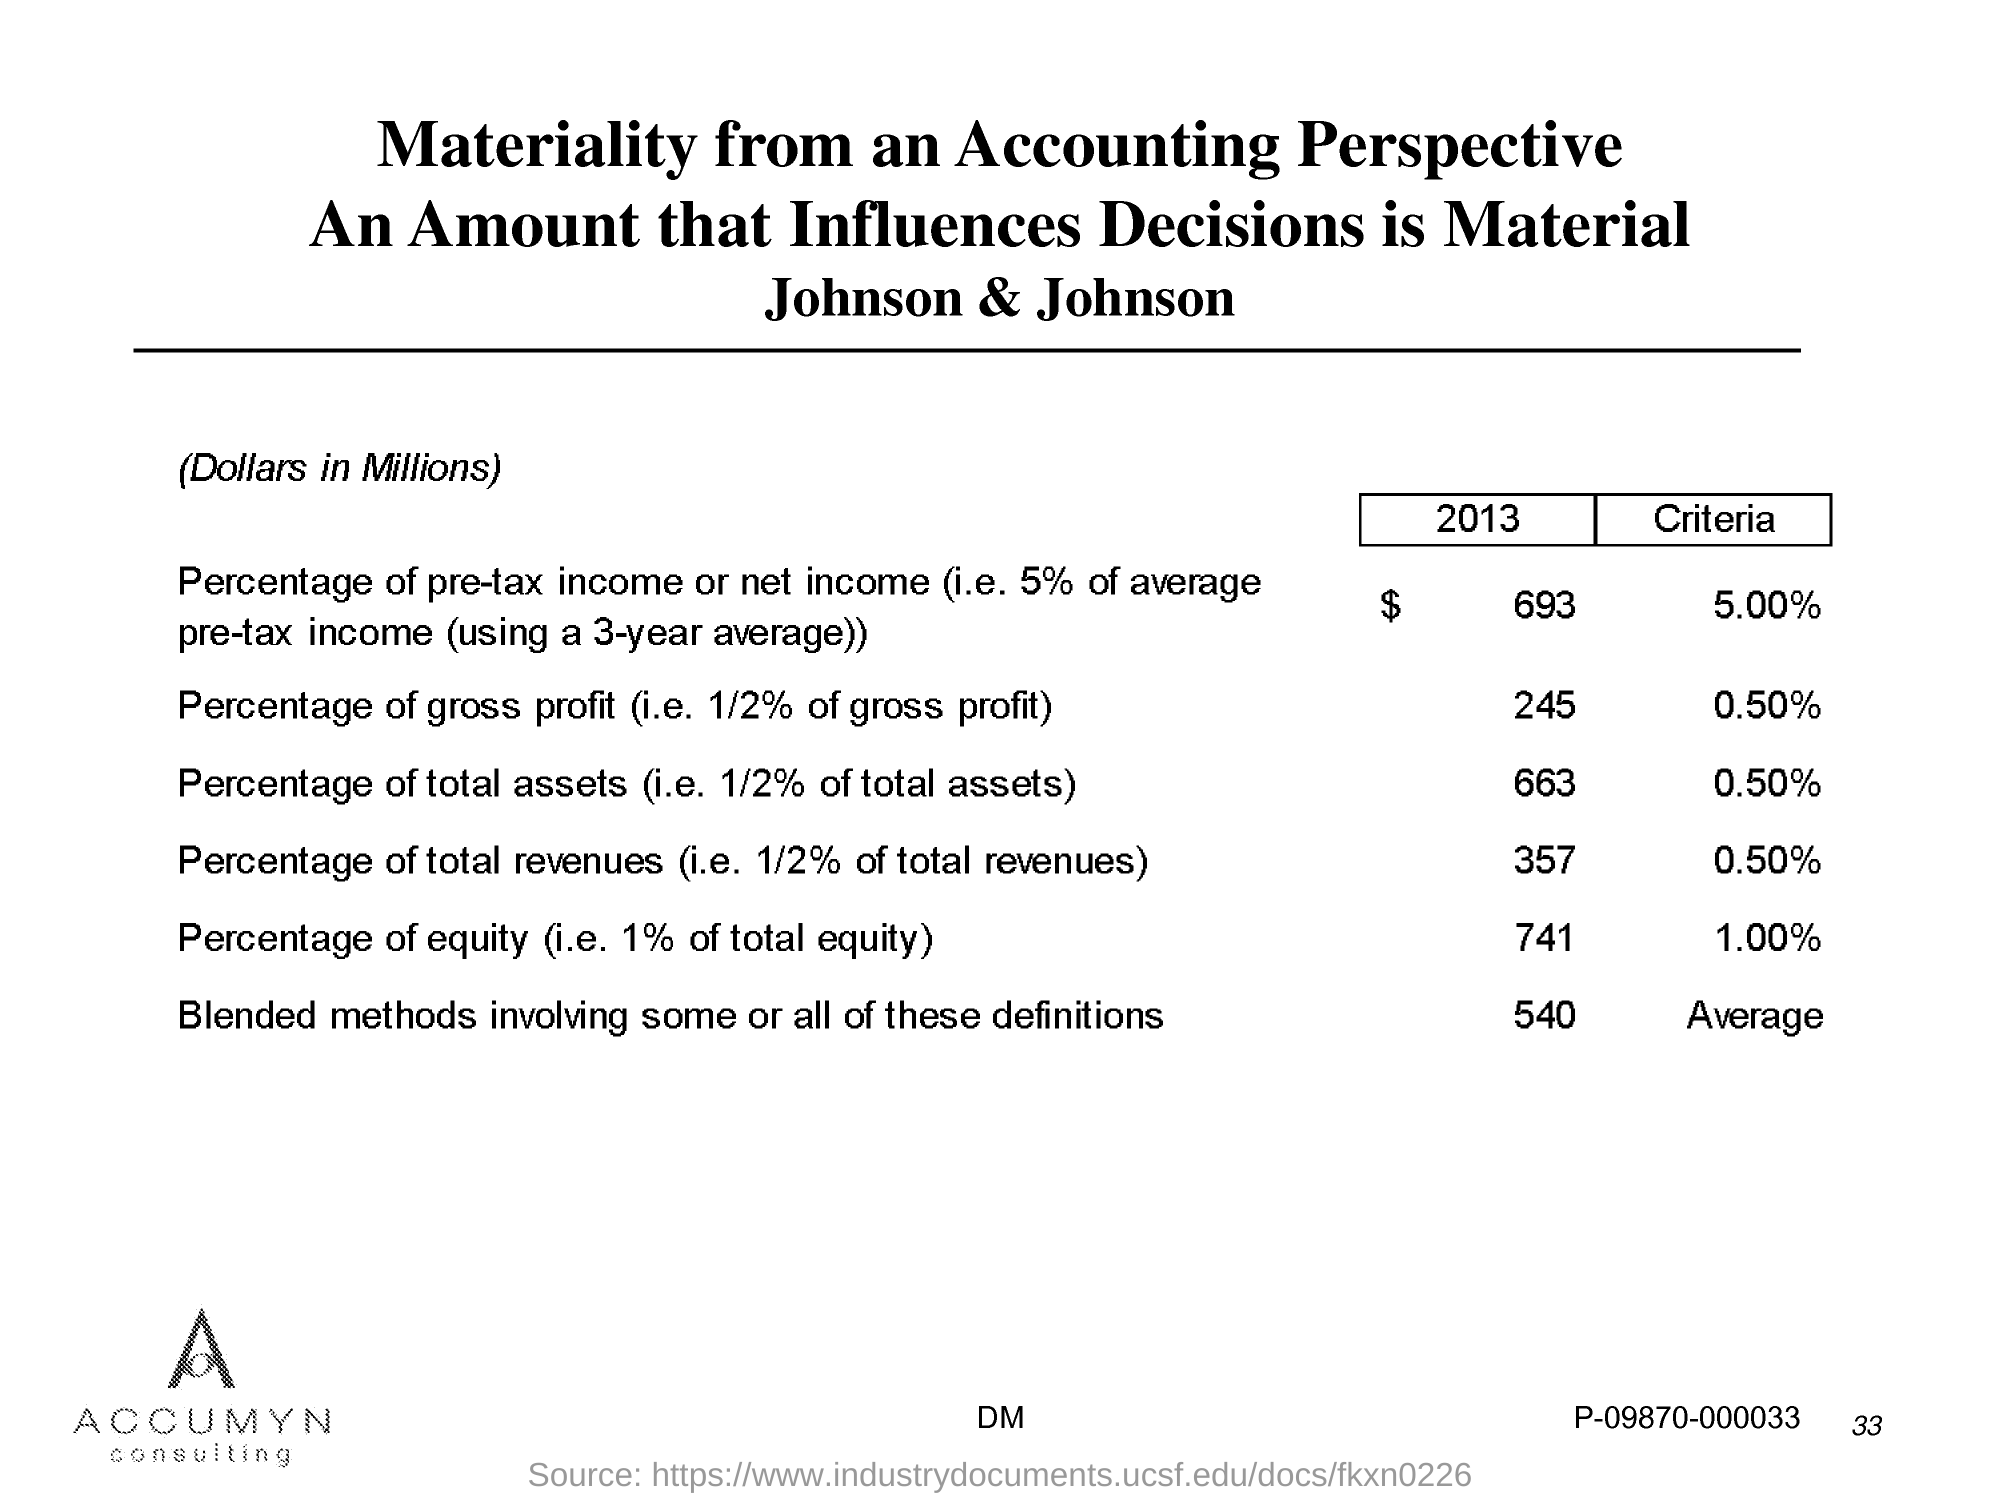Can you explain the significance of the percentages shown related to Johnson & Johnson's finances? The percentages represent criteria for determining the materiality of financial figures from an accounting standpoint. Materiality helps in assessing which figures are crucial enough to influence decision-making. For instance, 5% of the average pre-tax income amounts to $693 million, indicating substantial impacts on the financial statements. What does the 1% of total equity figure imply? The 1% of total equity, amounting to $741 million, signifies that any change or variation up to this amount is considered significant and potentially material to stakeholders and business decisions. 